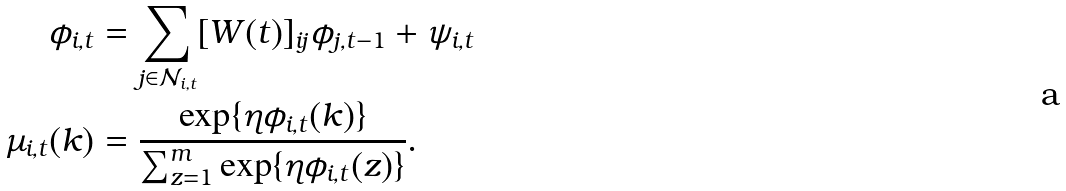Convert formula to latex. <formula><loc_0><loc_0><loc_500><loc_500>\phi _ { i , t } & = \sum _ { j \in \mathcal { N } _ { i , t } } [ W ( t ) ] _ { i j } \phi _ { j , t - 1 } + \psi _ { i , t } \\ \mu _ { i , t } ( k ) & = \frac { \exp \{ \eta \phi _ { i , t } ( k ) \} } { \sum _ { z = 1 } ^ { m } \exp \{ \eta \phi _ { i , t } ( z ) \} } .</formula> 